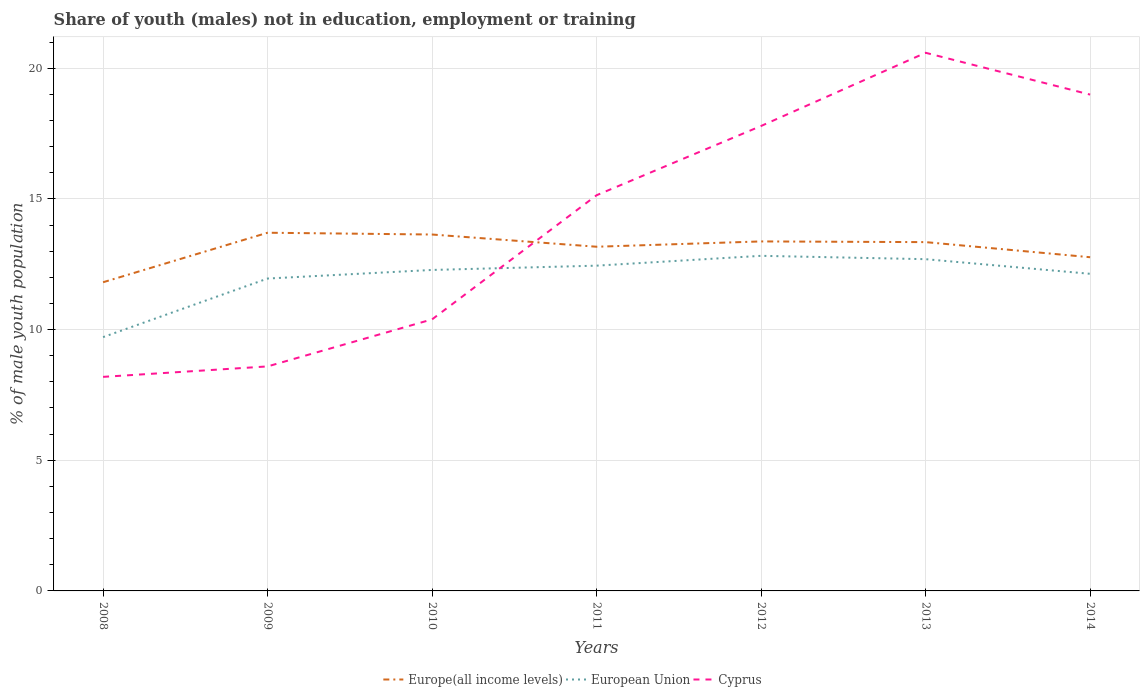How many different coloured lines are there?
Make the answer very short. 3. Does the line corresponding to Cyprus intersect with the line corresponding to European Union?
Offer a very short reply. Yes. Across all years, what is the maximum percentage of unemployed males population in in Cyprus?
Provide a succinct answer. 8.19. What is the total percentage of unemployed males population in in Europe(all income levels) in the graph?
Keep it short and to the point. 0.6. What is the difference between the highest and the second highest percentage of unemployed males population in in Cyprus?
Provide a short and direct response. 12.4. What is the difference between the highest and the lowest percentage of unemployed males population in in Europe(all income levels)?
Keep it short and to the point. 5. How many lines are there?
Your answer should be very brief. 3. What is the difference between two consecutive major ticks on the Y-axis?
Your answer should be very brief. 5. Are the values on the major ticks of Y-axis written in scientific E-notation?
Your answer should be very brief. No. Does the graph contain grids?
Provide a short and direct response. Yes. Where does the legend appear in the graph?
Offer a terse response. Bottom center. What is the title of the graph?
Ensure brevity in your answer.  Share of youth (males) not in education, employment or training. Does "Turks and Caicos Islands" appear as one of the legend labels in the graph?
Provide a succinct answer. No. What is the label or title of the X-axis?
Make the answer very short. Years. What is the label or title of the Y-axis?
Keep it short and to the point. % of male youth population. What is the % of male youth population of Europe(all income levels) in 2008?
Your response must be concise. 11.81. What is the % of male youth population in European Union in 2008?
Provide a succinct answer. 9.71. What is the % of male youth population of Cyprus in 2008?
Your answer should be compact. 8.19. What is the % of male youth population of Europe(all income levels) in 2009?
Your answer should be compact. 13.7. What is the % of male youth population in European Union in 2009?
Offer a very short reply. 11.95. What is the % of male youth population of Cyprus in 2009?
Make the answer very short. 8.59. What is the % of male youth population in Europe(all income levels) in 2010?
Your answer should be very brief. 13.64. What is the % of male youth population in European Union in 2010?
Keep it short and to the point. 12.28. What is the % of male youth population of Cyprus in 2010?
Give a very brief answer. 10.39. What is the % of male youth population of Europe(all income levels) in 2011?
Provide a short and direct response. 13.17. What is the % of male youth population in European Union in 2011?
Keep it short and to the point. 12.45. What is the % of male youth population in Cyprus in 2011?
Offer a very short reply. 15.14. What is the % of male youth population of Europe(all income levels) in 2012?
Provide a short and direct response. 13.37. What is the % of male youth population of European Union in 2012?
Your answer should be very brief. 12.82. What is the % of male youth population of Cyprus in 2012?
Offer a terse response. 17.79. What is the % of male youth population of Europe(all income levels) in 2013?
Ensure brevity in your answer.  13.35. What is the % of male youth population of European Union in 2013?
Keep it short and to the point. 12.69. What is the % of male youth population in Cyprus in 2013?
Keep it short and to the point. 20.59. What is the % of male youth population in Europe(all income levels) in 2014?
Provide a succinct answer. 12.77. What is the % of male youth population in European Union in 2014?
Keep it short and to the point. 12.13. What is the % of male youth population of Cyprus in 2014?
Provide a short and direct response. 18.99. Across all years, what is the maximum % of male youth population in Europe(all income levels)?
Give a very brief answer. 13.7. Across all years, what is the maximum % of male youth population in European Union?
Offer a terse response. 12.82. Across all years, what is the maximum % of male youth population in Cyprus?
Keep it short and to the point. 20.59. Across all years, what is the minimum % of male youth population in Europe(all income levels)?
Provide a succinct answer. 11.81. Across all years, what is the minimum % of male youth population of European Union?
Keep it short and to the point. 9.71. Across all years, what is the minimum % of male youth population of Cyprus?
Offer a terse response. 8.19. What is the total % of male youth population of Europe(all income levels) in the graph?
Make the answer very short. 91.81. What is the total % of male youth population of European Union in the graph?
Provide a short and direct response. 84.04. What is the total % of male youth population of Cyprus in the graph?
Give a very brief answer. 99.68. What is the difference between the % of male youth population in Europe(all income levels) in 2008 and that in 2009?
Provide a short and direct response. -1.89. What is the difference between the % of male youth population of European Union in 2008 and that in 2009?
Your response must be concise. -2.24. What is the difference between the % of male youth population in Cyprus in 2008 and that in 2009?
Provide a short and direct response. -0.4. What is the difference between the % of male youth population in Europe(all income levels) in 2008 and that in 2010?
Ensure brevity in your answer.  -1.83. What is the difference between the % of male youth population in European Union in 2008 and that in 2010?
Offer a terse response. -2.57. What is the difference between the % of male youth population of Europe(all income levels) in 2008 and that in 2011?
Ensure brevity in your answer.  -1.36. What is the difference between the % of male youth population of European Union in 2008 and that in 2011?
Provide a short and direct response. -2.73. What is the difference between the % of male youth population in Cyprus in 2008 and that in 2011?
Ensure brevity in your answer.  -6.95. What is the difference between the % of male youth population in Europe(all income levels) in 2008 and that in 2012?
Provide a short and direct response. -1.56. What is the difference between the % of male youth population in European Union in 2008 and that in 2012?
Make the answer very short. -3.11. What is the difference between the % of male youth population of Cyprus in 2008 and that in 2012?
Provide a short and direct response. -9.6. What is the difference between the % of male youth population of Europe(all income levels) in 2008 and that in 2013?
Provide a succinct answer. -1.54. What is the difference between the % of male youth population of European Union in 2008 and that in 2013?
Make the answer very short. -2.98. What is the difference between the % of male youth population in Cyprus in 2008 and that in 2013?
Make the answer very short. -12.4. What is the difference between the % of male youth population of Europe(all income levels) in 2008 and that in 2014?
Your answer should be very brief. -0.96. What is the difference between the % of male youth population of European Union in 2008 and that in 2014?
Offer a very short reply. -2.42. What is the difference between the % of male youth population in Cyprus in 2008 and that in 2014?
Offer a very short reply. -10.8. What is the difference between the % of male youth population of Europe(all income levels) in 2009 and that in 2010?
Provide a succinct answer. 0.07. What is the difference between the % of male youth population of European Union in 2009 and that in 2010?
Your answer should be compact. -0.33. What is the difference between the % of male youth population of Europe(all income levels) in 2009 and that in 2011?
Your response must be concise. 0.54. What is the difference between the % of male youth population in European Union in 2009 and that in 2011?
Your answer should be compact. -0.49. What is the difference between the % of male youth population of Cyprus in 2009 and that in 2011?
Keep it short and to the point. -6.55. What is the difference between the % of male youth population in Europe(all income levels) in 2009 and that in 2012?
Offer a terse response. 0.33. What is the difference between the % of male youth population of European Union in 2009 and that in 2012?
Offer a very short reply. -0.87. What is the difference between the % of male youth population in Europe(all income levels) in 2009 and that in 2013?
Your answer should be compact. 0.36. What is the difference between the % of male youth population of European Union in 2009 and that in 2013?
Offer a very short reply. -0.74. What is the difference between the % of male youth population of Cyprus in 2009 and that in 2013?
Your answer should be very brief. -12. What is the difference between the % of male youth population of Europe(all income levels) in 2009 and that in 2014?
Give a very brief answer. 0.94. What is the difference between the % of male youth population in European Union in 2009 and that in 2014?
Keep it short and to the point. -0.18. What is the difference between the % of male youth population of Cyprus in 2009 and that in 2014?
Your answer should be very brief. -10.4. What is the difference between the % of male youth population of Europe(all income levels) in 2010 and that in 2011?
Keep it short and to the point. 0.47. What is the difference between the % of male youth population in European Union in 2010 and that in 2011?
Your answer should be very brief. -0.16. What is the difference between the % of male youth population of Cyprus in 2010 and that in 2011?
Make the answer very short. -4.75. What is the difference between the % of male youth population in Europe(all income levels) in 2010 and that in 2012?
Make the answer very short. 0.26. What is the difference between the % of male youth population in European Union in 2010 and that in 2012?
Offer a very short reply. -0.54. What is the difference between the % of male youth population of Cyprus in 2010 and that in 2012?
Offer a terse response. -7.4. What is the difference between the % of male youth population in Europe(all income levels) in 2010 and that in 2013?
Your answer should be compact. 0.29. What is the difference between the % of male youth population of European Union in 2010 and that in 2013?
Your response must be concise. -0.41. What is the difference between the % of male youth population in Europe(all income levels) in 2010 and that in 2014?
Your answer should be compact. 0.87. What is the difference between the % of male youth population of European Union in 2010 and that in 2014?
Offer a very short reply. 0.15. What is the difference between the % of male youth population of Cyprus in 2010 and that in 2014?
Your response must be concise. -8.6. What is the difference between the % of male youth population in Europe(all income levels) in 2011 and that in 2012?
Your answer should be compact. -0.2. What is the difference between the % of male youth population in European Union in 2011 and that in 2012?
Make the answer very short. -0.38. What is the difference between the % of male youth population of Cyprus in 2011 and that in 2012?
Offer a terse response. -2.65. What is the difference between the % of male youth population of Europe(all income levels) in 2011 and that in 2013?
Ensure brevity in your answer.  -0.18. What is the difference between the % of male youth population of European Union in 2011 and that in 2013?
Make the answer very short. -0.25. What is the difference between the % of male youth population of Cyprus in 2011 and that in 2013?
Your answer should be compact. -5.45. What is the difference between the % of male youth population in Europe(all income levels) in 2011 and that in 2014?
Your answer should be compact. 0.4. What is the difference between the % of male youth population in European Union in 2011 and that in 2014?
Give a very brief answer. 0.31. What is the difference between the % of male youth population in Cyprus in 2011 and that in 2014?
Provide a succinct answer. -3.85. What is the difference between the % of male youth population in Europe(all income levels) in 2012 and that in 2013?
Offer a terse response. 0.03. What is the difference between the % of male youth population of European Union in 2012 and that in 2013?
Your answer should be very brief. 0.13. What is the difference between the % of male youth population of Europe(all income levels) in 2012 and that in 2014?
Your answer should be very brief. 0.6. What is the difference between the % of male youth population of European Union in 2012 and that in 2014?
Ensure brevity in your answer.  0.69. What is the difference between the % of male youth population in Europe(all income levels) in 2013 and that in 2014?
Offer a terse response. 0.58. What is the difference between the % of male youth population of European Union in 2013 and that in 2014?
Offer a terse response. 0.56. What is the difference between the % of male youth population in Cyprus in 2013 and that in 2014?
Provide a succinct answer. 1.6. What is the difference between the % of male youth population of Europe(all income levels) in 2008 and the % of male youth population of European Union in 2009?
Keep it short and to the point. -0.14. What is the difference between the % of male youth population in Europe(all income levels) in 2008 and the % of male youth population in Cyprus in 2009?
Provide a short and direct response. 3.22. What is the difference between the % of male youth population in European Union in 2008 and the % of male youth population in Cyprus in 2009?
Your response must be concise. 1.12. What is the difference between the % of male youth population in Europe(all income levels) in 2008 and the % of male youth population in European Union in 2010?
Your answer should be very brief. -0.47. What is the difference between the % of male youth population in Europe(all income levels) in 2008 and the % of male youth population in Cyprus in 2010?
Ensure brevity in your answer.  1.42. What is the difference between the % of male youth population in European Union in 2008 and the % of male youth population in Cyprus in 2010?
Your answer should be very brief. -0.68. What is the difference between the % of male youth population of Europe(all income levels) in 2008 and the % of male youth population of European Union in 2011?
Ensure brevity in your answer.  -0.63. What is the difference between the % of male youth population of Europe(all income levels) in 2008 and the % of male youth population of Cyprus in 2011?
Your answer should be very brief. -3.33. What is the difference between the % of male youth population of European Union in 2008 and the % of male youth population of Cyprus in 2011?
Your response must be concise. -5.43. What is the difference between the % of male youth population in Europe(all income levels) in 2008 and the % of male youth population in European Union in 2012?
Give a very brief answer. -1.01. What is the difference between the % of male youth population in Europe(all income levels) in 2008 and the % of male youth population in Cyprus in 2012?
Offer a very short reply. -5.98. What is the difference between the % of male youth population of European Union in 2008 and the % of male youth population of Cyprus in 2012?
Ensure brevity in your answer.  -8.08. What is the difference between the % of male youth population in Europe(all income levels) in 2008 and the % of male youth population in European Union in 2013?
Your answer should be compact. -0.88. What is the difference between the % of male youth population in Europe(all income levels) in 2008 and the % of male youth population in Cyprus in 2013?
Offer a very short reply. -8.78. What is the difference between the % of male youth population of European Union in 2008 and the % of male youth population of Cyprus in 2013?
Ensure brevity in your answer.  -10.88. What is the difference between the % of male youth population in Europe(all income levels) in 2008 and the % of male youth population in European Union in 2014?
Offer a terse response. -0.32. What is the difference between the % of male youth population of Europe(all income levels) in 2008 and the % of male youth population of Cyprus in 2014?
Your response must be concise. -7.18. What is the difference between the % of male youth population of European Union in 2008 and the % of male youth population of Cyprus in 2014?
Offer a very short reply. -9.28. What is the difference between the % of male youth population in Europe(all income levels) in 2009 and the % of male youth population in European Union in 2010?
Your answer should be very brief. 1.42. What is the difference between the % of male youth population of Europe(all income levels) in 2009 and the % of male youth population of Cyprus in 2010?
Offer a very short reply. 3.31. What is the difference between the % of male youth population in European Union in 2009 and the % of male youth population in Cyprus in 2010?
Provide a short and direct response. 1.56. What is the difference between the % of male youth population of Europe(all income levels) in 2009 and the % of male youth population of European Union in 2011?
Your answer should be compact. 1.26. What is the difference between the % of male youth population of Europe(all income levels) in 2009 and the % of male youth population of Cyprus in 2011?
Give a very brief answer. -1.44. What is the difference between the % of male youth population of European Union in 2009 and the % of male youth population of Cyprus in 2011?
Keep it short and to the point. -3.19. What is the difference between the % of male youth population in Europe(all income levels) in 2009 and the % of male youth population in European Union in 2012?
Offer a very short reply. 0.88. What is the difference between the % of male youth population in Europe(all income levels) in 2009 and the % of male youth population in Cyprus in 2012?
Your answer should be very brief. -4.09. What is the difference between the % of male youth population of European Union in 2009 and the % of male youth population of Cyprus in 2012?
Offer a very short reply. -5.84. What is the difference between the % of male youth population in Europe(all income levels) in 2009 and the % of male youth population in European Union in 2013?
Provide a succinct answer. 1.01. What is the difference between the % of male youth population of Europe(all income levels) in 2009 and the % of male youth population of Cyprus in 2013?
Your answer should be compact. -6.89. What is the difference between the % of male youth population of European Union in 2009 and the % of male youth population of Cyprus in 2013?
Your answer should be compact. -8.64. What is the difference between the % of male youth population in Europe(all income levels) in 2009 and the % of male youth population in European Union in 2014?
Offer a terse response. 1.57. What is the difference between the % of male youth population of Europe(all income levels) in 2009 and the % of male youth population of Cyprus in 2014?
Provide a succinct answer. -5.29. What is the difference between the % of male youth population in European Union in 2009 and the % of male youth population in Cyprus in 2014?
Provide a succinct answer. -7.04. What is the difference between the % of male youth population of Europe(all income levels) in 2010 and the % of male youth population of European Union in 2011?
Make the answer very short. 1.19. What is the difference between the % of male youth population of Europe(all income levels) in 2010 and the % of male youth population of Cyprus in 2011?
Give a very brief answer. -1.5. What is the difference between the % of male youth population of European Union in 2010 and the % of male youth population of Cyprus in 2011?
Give a very brief answer. -2.86. What is the difference between the % of male youth population in Europe(all income levels) in 2010 and the % of male youth population in European Union in 2012?
Keep it short and to the point. 0.82. What is the difference between the % of male youth population of Europe(all income levels) in 2010 and the % of male youth population of Cyprus in 2012?
Provide a succinct answer. -4.15. What is the difference between the % of male youth population of European Union in 2010 and the % of male youth population of Cyprus in 2012?
Your answer should be very brief. -5.51. What is the difference between the % of male youth population in Europe(all income levels) in 2010 and the % of male youth population in European Union in 2013?
Make the answer very short. 0.94. What is the difference between the % of male youth population in Europe(all income levels) in 2010 and the % of male youth population in Cyprus in 2013?
Keep it short and to the point. -6.95. What is the difference between the % of male youth population in European Union in 2010 and the % of male youth population in Cyprus in 2013?
Make the answer very short. -8.31. What is the difference between the % of male youth population of Europe(all income levels) in 2010 and the % of male youth population of European Union in 2014?
Your answer should be compact. 1.5. What is the difference between the % of male youth population of Europe(all income levels) in 2010 and the % of male youth population of Cyprus in 2014?
Keep it short and to the point. -5.35. What is the difference between the % of male youth population in European Union in 2010 and the % of male youth population in Cyprus in 2014?
Your response must be concise. -6.71. What is the difference between the % of male youth population in Europe(all income levels) in 2011 and the % of male youth population in European Union in 2012?
Give a very brief answer. 0.35. What is the difference between the % of male youth population of Europe(all income levels) in 2011 and the % of male youth population of Cyprus in 2012?
Provide a short and direct response. -4.62. What is the difference between the % of male youth population in European Union in 2011 and the % of male youth population in Cyprus in 2012?
Your answer should be compact. -5.34. What is the difference between the % of male youth population in Europe(all income levels) in 2011 and the % of male youth population in European Union in 2013?
Provide a succinct answer. 0.48. What is the difference between the % of male youth population in Europe(all income levels) in 2011 and the % of male youth population in Cyprus in 2013?
Keep it short and to the point. -7.42. What is the difference between the % of male youth population of European Union in 2011 and the % of male youth population of Cyprus in 2013?
Keep it short and to the point. -8.14. What is the difference between the % of male youth population in Europe(all income levels) in 2011 and the % of male youth population in European Union in 2014?
Give a very brief answer. 1.04. What is the difference between the % of male youth population of Europe(all income levels) in 2011 and the % of male youth population of Cyprus in 2014?
Offer a terse response. -5.82. What is the difference between the % of male youth population of European Union in 2011 and the % of male youth population of Cyprus in 2014?
Your answer should be compact. -6.54. What is the difference between the % of male youth population in Europe(all income levels) in 2012 and the % of male youth population in European Union in 2013?
Give a very brief answer. 0.68. What is the difference between the % of male youth population of Europe(all income levels) in 2012 and the % of male youth population of Cyprus in 2013?
Give a very brief answer. -7.22. What is the difference between the % of male youth population of European Union in 2012 and the % of male youth population of Cyprus in 2013?
Offer a terse response. -7.77. What is the difference between the % of male youth population of Europe(all income levels) in 2012 and the % of male youth population of European Union in 2014?
Your response must be concise. 1.24. What is the difference between the % of male youth population in Europe(all income levels) in 2012 and the % of male youth population in Cyprus in 2014?
Provide a short and direct response. -5.62. What is the difference between the % of male youth population in European Union in 2012 and the % of male youth population in Cyprus in 2014?
Make the answer very short. -6.17. What is the difference between the % of male youth population in Europe(all income levels) in 2013 and the % of male youth population in European Union in 2014?
Provide a short and direct response. 1.21. What is the difference between the % of male youth population in Europe(all income levels) in 2013 and the % of male youth population in Cyprus in 2014?
Give a very brief answer. -5.64. What is the difference between the % of male youth population in European Union in 2013 and the % of male youth population in Cyprus in 2014?
Your answer should be compact. -6.3. What is the average % of male youth population of Europe(all income levels) per year?
Your answer should be very brief. 13.12. What is the average % of male youth population of European Union per year?
Offer a terse response. 12.01. What is the average % of male youth population of Cyprus per year?
Offer a terse response. 14.24. In the year 2008, what is the difference between the % of male youth population of Europe(all income levels) and % of male youth population of European Union?
Make the answer very short. 2.1. In the year 2008, what is the difference between the % of male youth population in Europe(all income levels) and % of male youth population in Cyprus?
Keep it short and to the point. 3.62. In the year 2008, what is the difference between the % of male youth population in European Union and % of male youth population in Cyprus?
Your response must be concise. 1.52. In the year 2009, what is the difference between the % of male youth population of Europe(all income levels) and % of male youth population of European Union?
Your answer should be compact. 1.75. In the year 2009, what is the difference between the % of male youth population of Europe(all income levels) and % of male youth population of Cyprus?
Give a very brief answer. 5.11. In the year 2009, what is the difference between the % of male youth population of European Union and % of male youth population of Cyprus?
Keep it short and to the point. 3.36. In the year 2010, what is the difference between the % of male youth population in Europe(all income levels) and % of male youth population in European Union?
Your answer should be compact. 1.36. In the year 2010, what is the difference between the % of male youth population of Europe(all income levels) and % of male youth population of Cyprus?
Keep it short and to the point. 3.25. In the year 2010, what is the difference between the % of male youth population in European Union and % of male youth population in Cyprus?
Keep it short and to the point. 1.89. In the year 2011, what is the difference between the % of male youth population in Europe(all income levels) and % of male youth population in European Union?
Your answer should be very brief. 0.72. In the year 2011, what is the difference between the % of male youth population in Europe(all income levels) and % of male youth population in Cyprus?
Provide a succinct answer. -1.97. In the year 2011, what is the difference between the % of male youth population in European Union and % of male youth population in Cyprus?
Your answer should be compact. -2.69. In the year 2012, what is the difference between the % of male youth population in Europe(all income levels) and % of male youth population in European Union?
Offer a terse response. 0.55. In the year 2012, what is the difference between the % of male youth population of Europe(all income levels) and % of male youth population of Cyprus?
Your answer should be very brief. -4.42. In the year 2012, what is the difference between the % of male youth population of European Union and % of male youth population of Cyprus?
Your answer should be very brief. -4.97. In the year 2013, what is the difference between the % of male youth population of Europe(all income levels) and % of male youth population of European Union?
Provide a short and direct response. 0.65. In the year 2013, what is the difference between the % of male youth population of Europe(all income levels) and % of male youth population of Cyprus?
Your response must be concise. -7.24. In the year 2013, what is the difference between the % of male youth population in European Union and % of male youth population in Cyprus?
Keep it short and to the point. -7.9. In the year 2014, what is the difference between the % of male youth population in Europe(all income levels) and % of male youth population in European Union?
Ensure brevity in your answer.  0.63. In the year 2014, what is the difference between the % of male youth population in Europe(all income levels) and % of male youth population in Cyprus?
Provide a short and direct response. -6.22. In the year 2014, what is the difference between the % of male youth population in European Union and % of male youth population in Cyprus?
Give a very brief answer. -6.86. What is the ratio of the % of male youth population of Europe(all income levels) in 2008 to that in 2009?
Offer a terse response. 0.86. What is the ratio of the % of male youth population in European Union in 2008 to that in 2009?
Ensure brevity in your answer.  0.81. What is the ratio of the % of male youth population in Cyprus in 2008 to that in 2009?
Make the answer very short. 0.95. What is the ratio of the % of male youth population of Europe(all income levels) in 2008 to that in 2010?
Provide a short and direct response. 0.87. What is the ratio of the % of male youth population of European Union in 2008 to that in 2010?
Keep it short and to the point. 0.79. What is the ratio of the % of male youth population of Cyprus in 2008 to that in 2010?
Offer a terse response. 0.79. What is the ratio of the % of male youth population in Europe(all income levels) in 2008 to that in 2011?
Offer a very short reply. 0.9. What is the ratio of the % of male youth population in European Union in 2008 to that in 2011?
Your response must be concise. 0.78. What is the ratio of the % of male youth population in Cyprus in 2008 to that in 2011?
Make the answer very short. 0.54. What is the ratio of the % of male youth population in Europe(all income levels) in 2008 to that in 2012?
Your answer should be compact. 0.88. What is the ratio of the % of male youth population of European Union in 2008 to that in 2012?
Your answer should be very brief. 0.76. What is the ratio of the % of male youth population in Cyprus in 2008 to that in 2012?
Give a very brief answer. 0.46. What is the ratio of the % of male youth population in Europe(all income levels) in 2008 to that in 2013?
Provide a short and direct response. 0.89. What is the ratio of the % of male youth population in European Union in 2008 to that in 2013?
Provide a succinct answer. 0.77. What is the ratio of the % of male youth population in Cyprus in 2008 to that in 2013?
Your answer should be very brief. 0.4. What is the ratio of the % of male youth population of Europe(all income levels) in 2008 to that in 2014?
Your response must be concise. 0.93. What is the ratio of the % of male youth population in European Union in 2008 to that in 2014?
Make the answer very short. 0.8. What is the ratio of the % of male youth population in Cyprus in 2008 to that in 2014?
Your answer should be compact. 0.43. What is the ratio of the % of male youth population in Europe(all income levels) in 2009 to that in 2010?
Your response must be concise. 1. What is the ratio of the % of male youth population in European Union in 2009 to that in 2010?
Your response must be concise. 0.97. What is the ratio of the % of male youth population of Cyprus in 2009 to that in 2010?
Your response must be concise. 0.83. What is the ratio of the % of male youth population in Europe(all income levels) in 2009 to that in 2011?
Provide a short and direct response. 1.04. What is the ratio of the % of male youth population of European Union in 2009 to that in 2011?
Ensure brevity in your answer.  0.96. What is the ratio of the % of male youth population of Cyprus in 2009 to that in 2011?
Make the answer very short. 0.57. What is the ratio of the % of male youth population of Europe(all income levels) in 2009 to that in 2012?
Offer a terse response. 1.02. What is the ratio of the % of male youth population of European Union in 2009 to that in 2012?
Ensure brevity in your answer.  0.93. What is the ratio of the % of male youth population in Cyprus in 2009 to that in 2012?
Offer a terse response. 0.48. What is the ratio of the % of male youth population in Europe(all income levels) in 2009 to that in 2013?
Offer a very short reply. 1.03. What is the ratio of the % of male youth population in European Union in 2009 to that in 2013?
Make the answer very short. 0.94. What is the ratio of the % of male youth population of Cyprus in 2009 to that in 2013?
Give a very brief answer. 0.42. What is the ratio of the % of male youth population in Europe(all income levels) in 2009 to that in 2014?
Your answer should be very brief. 1.07. What is the ratio of the % of male youth population of European Union in 2009 to that in 2014?
Your response must be concise. 0.99. What is the ratio of the % of male youth population of Cyprus in 2009 to that in 2014?
Keep it short and to the point. 0.45. What is the ratio of the % of male youth population of Europe(all income levels) in 2010 to that in 2011?
Give a very brief answer. 1.04. What is the ratio of the % of male youth population of Cyprus in 2010 to that in 2011?
Provide a succinct answer. 0.69. What is the ratio of the % of male youth population of Europe(all income levels) in 2010 to that in 2012?
Give a very brief answer. 1.02. What is the ratio of the % of male youth population of European Union in 2010 to that in 2012?
Give a very brief answer. 0.96. What is the ratio of the % of male youth population of Cyprus in 2010 to that in 2012?
Keep it short and to the point. 0.58. What is the ratio of the % of male youth population in Europe(all income levels) in 2010 to that in 2013?
Your answer should be compact. 1.02. What is the ratio of the % of male youth population in European Union in 2010 to that in 2013?
Provide a short and direct response. 0.97. What is the ratio of the % of male youth population in Cyprus in 2010 to that in 2013?
Offer a terse response. 0.5. What is the ratio of the % of male youth population of Europe(all income levels) in 2010 to that in 2014?
Your answer should be very brief. 1.07. What is the ratio of the % of male youth population of European Union in 2010 to that in 2014?
Your response must be concise. 1.01. What is the ratio of the % of male youth population of Cyprus in 2010 to that in 2014?
Make the answer very short. 0.55. What is the ratio of the % of male youth population in European Union in 2011 to that in 2012?
Provide a short and direct response. 0.97. What is the ratio of the % of male youth population in Cyprus in 2011 to that in 2012?
Your answer should be very brief. 0.85. What is the ratio of the % of male youth population in Europe(all income levels) in 2011 to that in 2013?
Offer a very short reply. 0.99. What is the ratio of the % of male youth population of European Union in 2011 to that in 2013?
Keep it short and to the point. 0.98. What is the ratio of the % of male youth population of Cyprus in 2011 to that in 2013?
Give a very brief answer. 0.74. What is the ratio of the % of male youth population in Europe(all income levels) in 2011 to that in 2014?
Ensure brevity in your answer.  1.03. What is the ratio of the % of male youth population in European Union in 2011 to that in 2014?
Your answer should be compact. 1.03. What is the ratio of the % of male youth population in Cyprus in 2011 to that in 2014?
Keep it short and to the point. 0.8. What is the ratio of the % of male youth population in Europe(all income levels) in 2012 to that in 2013?
Your answer should be very brief. 1. What is the ratio of the % of male youth population of Cyprus in 2012 to that in 2013?
Ensure brevity in your answer.  0.86. What is the ratio of the % of male youth population of Europe(all income levels) in 2012 to that in 2014?
Your answer should be very brief. 1.05. What is the ratio of the % of male youth population in European Union in 2012 to that in 2014?
Provide a short and direct response. 1.06. What is the ratio of the % of male youth population in Cyprus in 2012 to that in 2014?
Make the answer very short. 0.94. What is the ratio of the % of male youth population of Europe(all income levels) in 2013 to that in 2014?
Ensure brevity in your answer.  1.05. What is the ratio of the % of male youth population in European Union in 2013 to that in 2014?
Ensure brevity in your answer.  1.05. What is the ratio of the % of male youth population in Cyprus in 2013 to that in 2014?
Keep it short and to the point. 1.08. What is the difference between the highest and the second highest % of male youth population of Europe(all income levels)?
Give a very brief answer. 0.07. What is the difference between the highest and the second highest % of male youth population of European Union?
Offer a terse response. 0.13. What is the difference between the highest and the lowest % of male youth population in Europe(all income levels)?
Provide a succinct answer. 1.89. What is the difference between the highest and the lowest % of male youth population in European Union?
Provide a succinct answer. 3.11. 